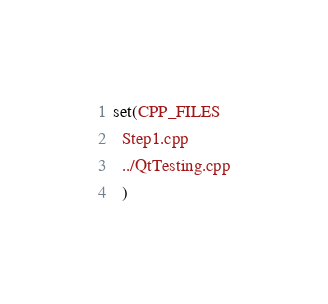Convert code to text. <code><loc_0><loc_0><loc_500><loc_500><_CMake_>set(CPP_FILES
  Step1.cpp
  ../QtTesting.cpp
  )
</code> 